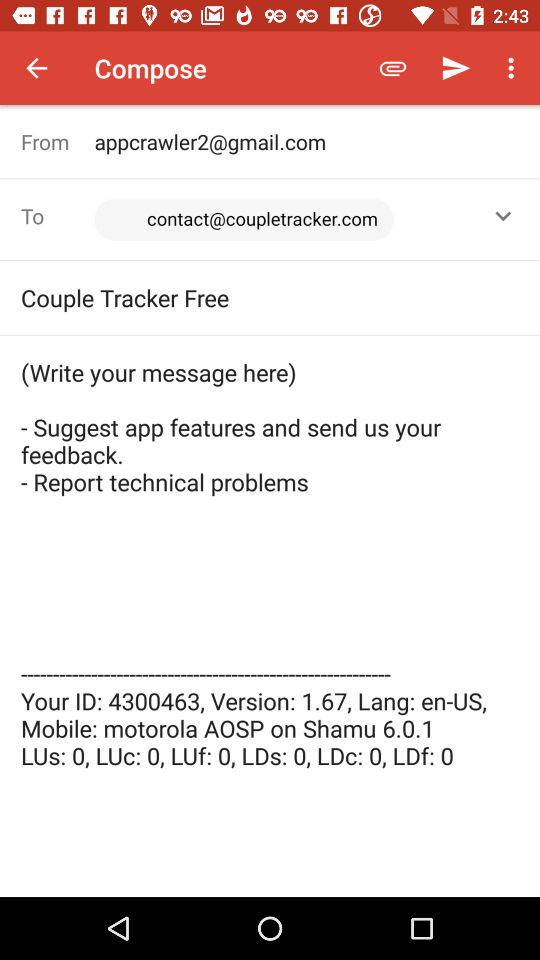What is the version number? The version numbers are 1.67 and 6.0.1. 